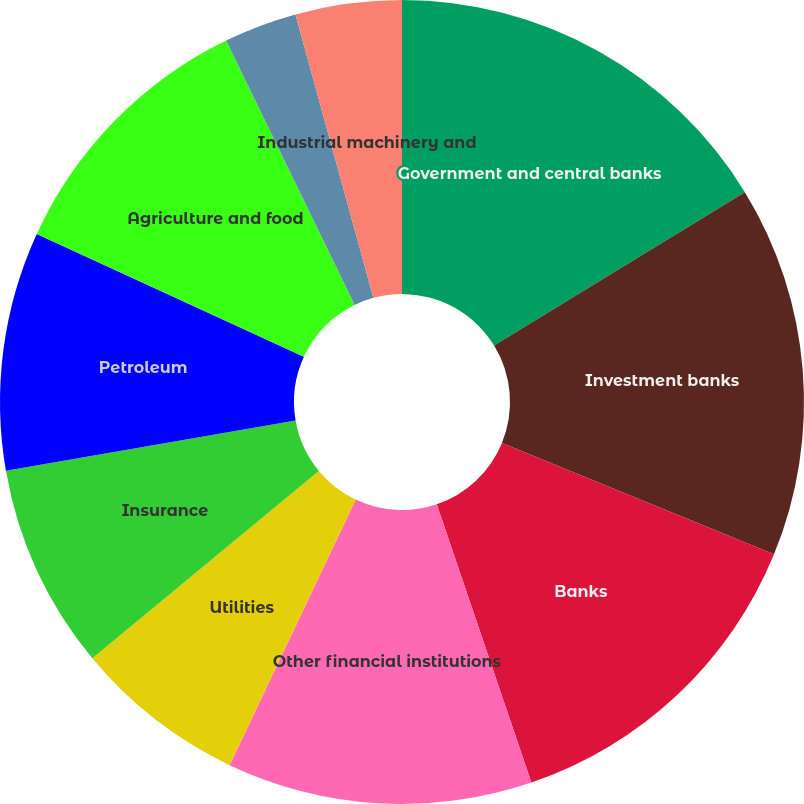Convert chart. <chart><loc_0><loc_0><loc_500><loc_500><pie_chart><fcel>Government and central banks<fcel>Investment banks<fcel>Banks<fcel>Other financial institutions<fcel>Utilities<fcel>Insurance<fcel>Petroleum<fcel>Agriculture and food<fcel>Telephone and cable<fcel>Industrial machinery and<nl><fcel>16.26%<fcel>14.93%<fcel>13.6%<fcel>12.27%<fcel>6.94%<fcel>8.27%<fcel>9.6%<fcel>10.93%<fcel>2.94%<fcel>4.27%<nl></chart> 